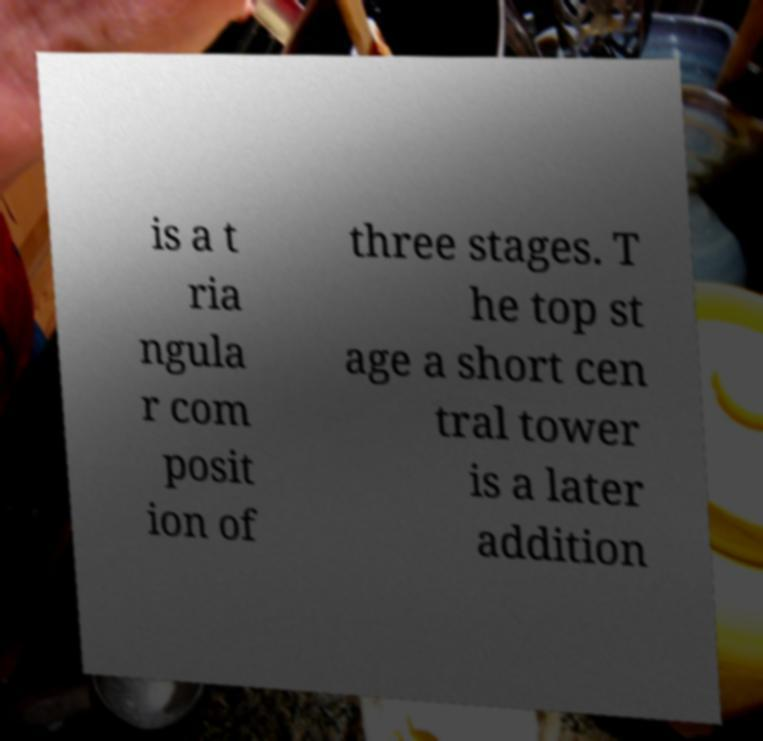Please identify and transcribe the text found in this image. is a t ria ngula r com posit ion of three stages. T he top st age a short cen tral tower is a later addition 